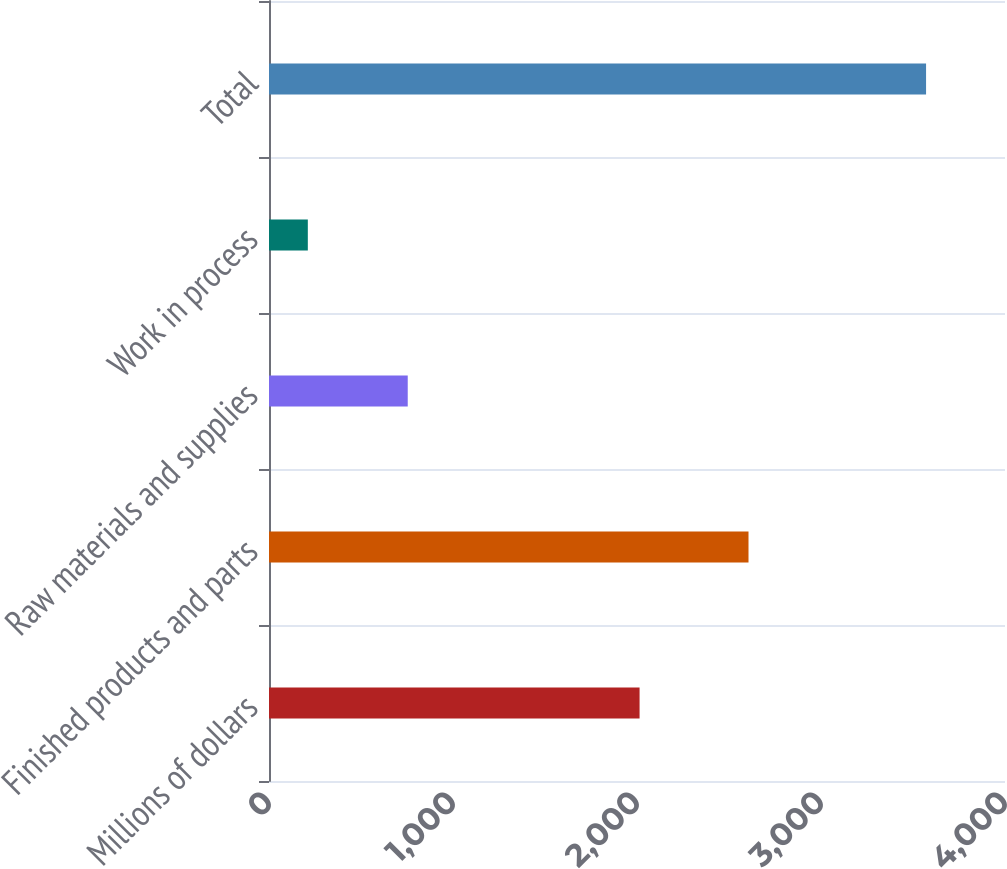<chart> <loc_0><loc_0><loc_500><loc_500><bar_chart><fcel>Millions of dollars<fcel>Finished products and parts<fcel>Raw materials and supplies<fcel>Work in process<fcel>Total<nl><fcel>2014<fcel>2606<fcel>754<fcel>211<fcel>3571<nl></chart> 